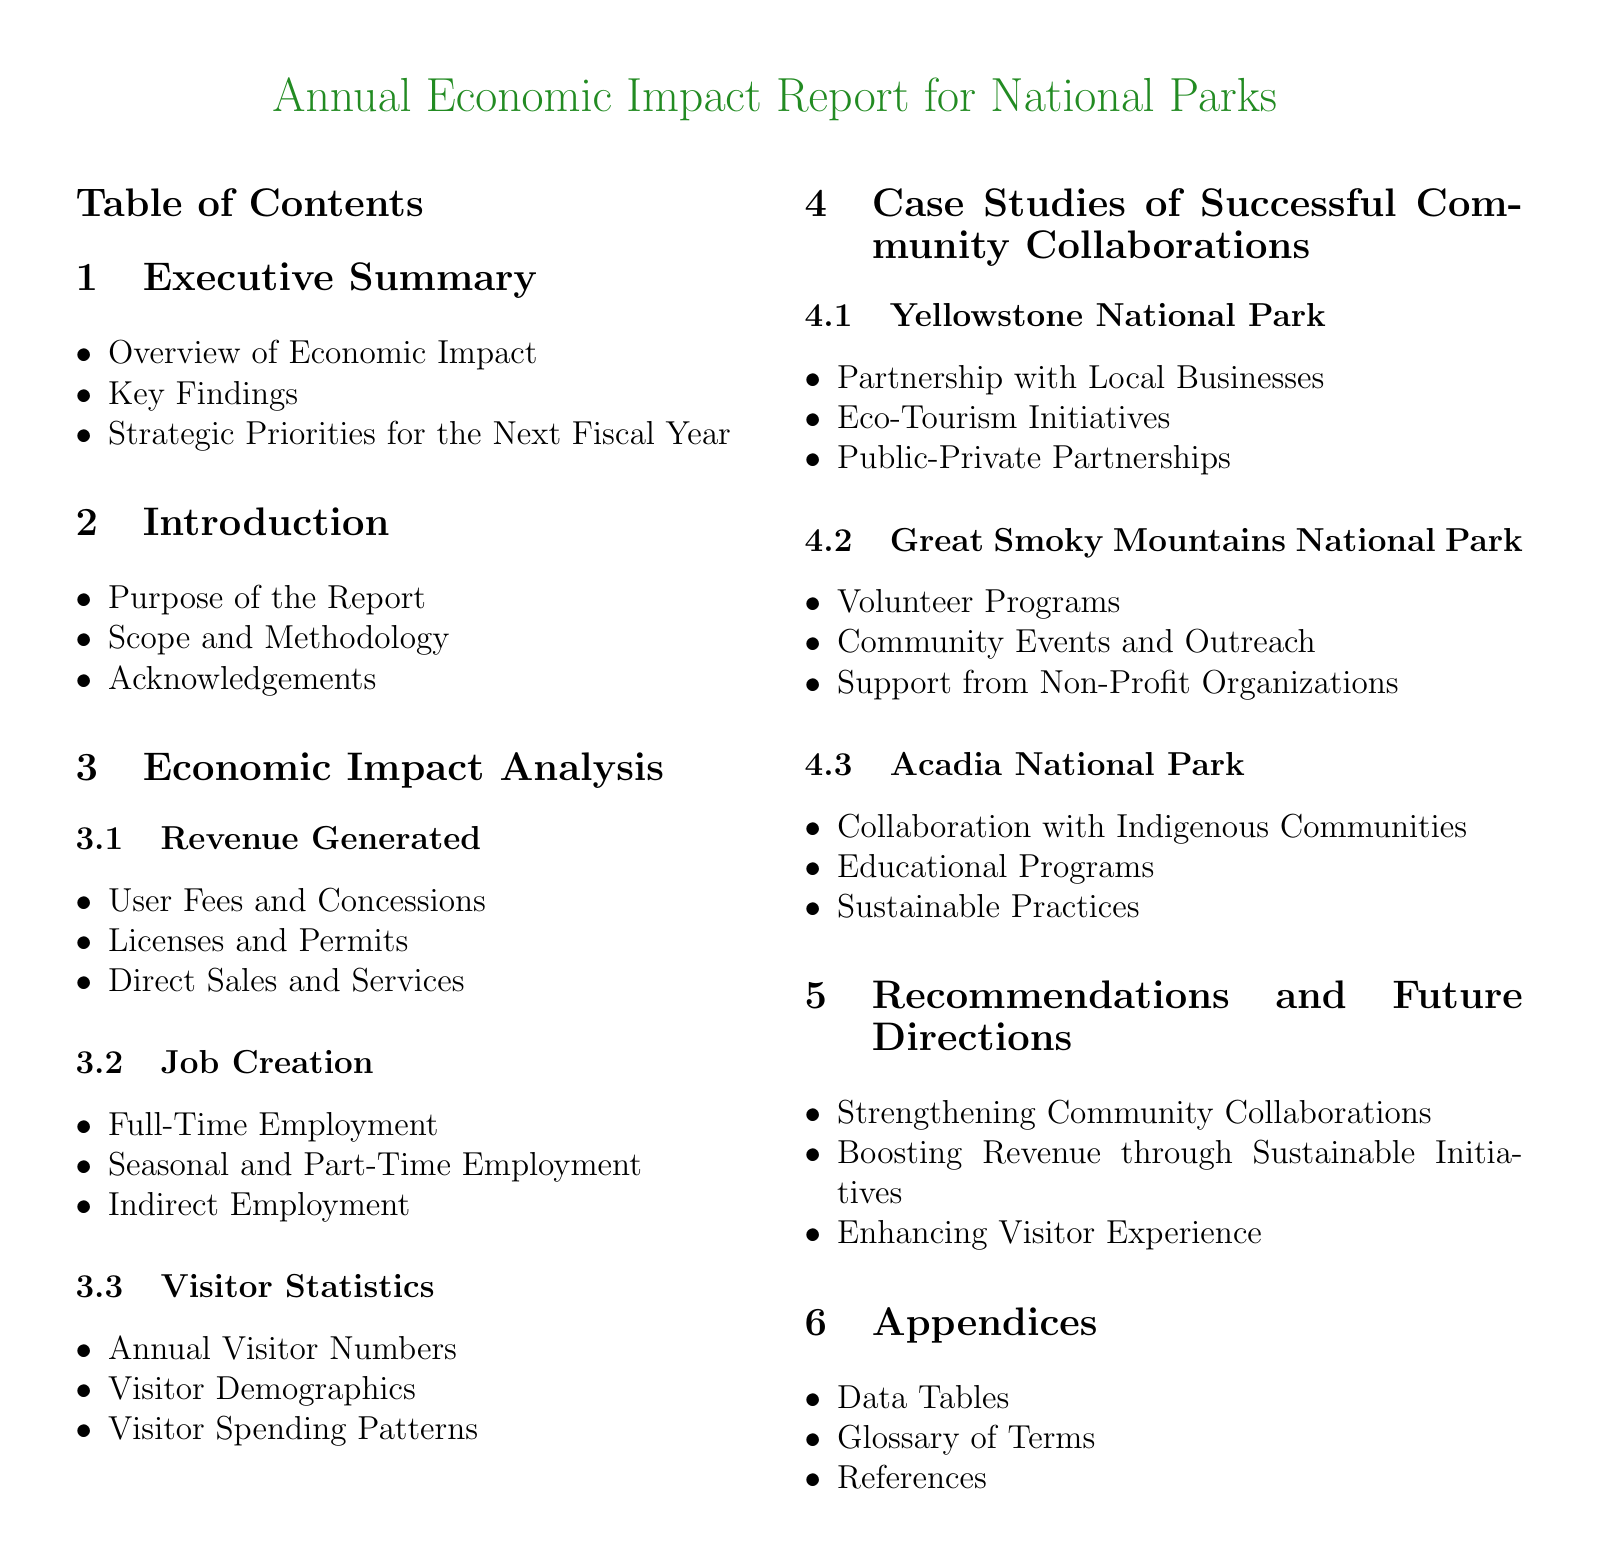What are the key findings? The key findings are summarized in the executive summary section.
Answer: Key Findings What is the purpose of this report? The purpose of this report is outlined in the introduction section.
Answer: Purpose of the Report What is the subsection that discusses job creation? The subsection discussing job creation can be found under Economic Impact Analysis.
Answer: Job Creation Which national park is associated with public-private partnerships? Yellowstone National Park is highlighted for its public-private partnerships in the case studies section.
Answer: Yellowstone National Park What type of employment is covered under seasonal and part-time employment? This type of employment is detailed under the Job Creation subsection.
Answer: Seasonal and Part-Time Employment What does the report recommend for future directions? Recommendations and future directions are provided in the recommendations section.
Answer: Strengthening Community Collaborations How many community collaboration case studies are presented? The case studies present a total of three national parks.
Answer: Three What is included in the appendices? The appendices contain several items listed in that section.
Answer: Data Tables What audience is the report aimed at? The intended audience can be inferred from the report's content and purpose section.
Answer: Public and Stakeholders 